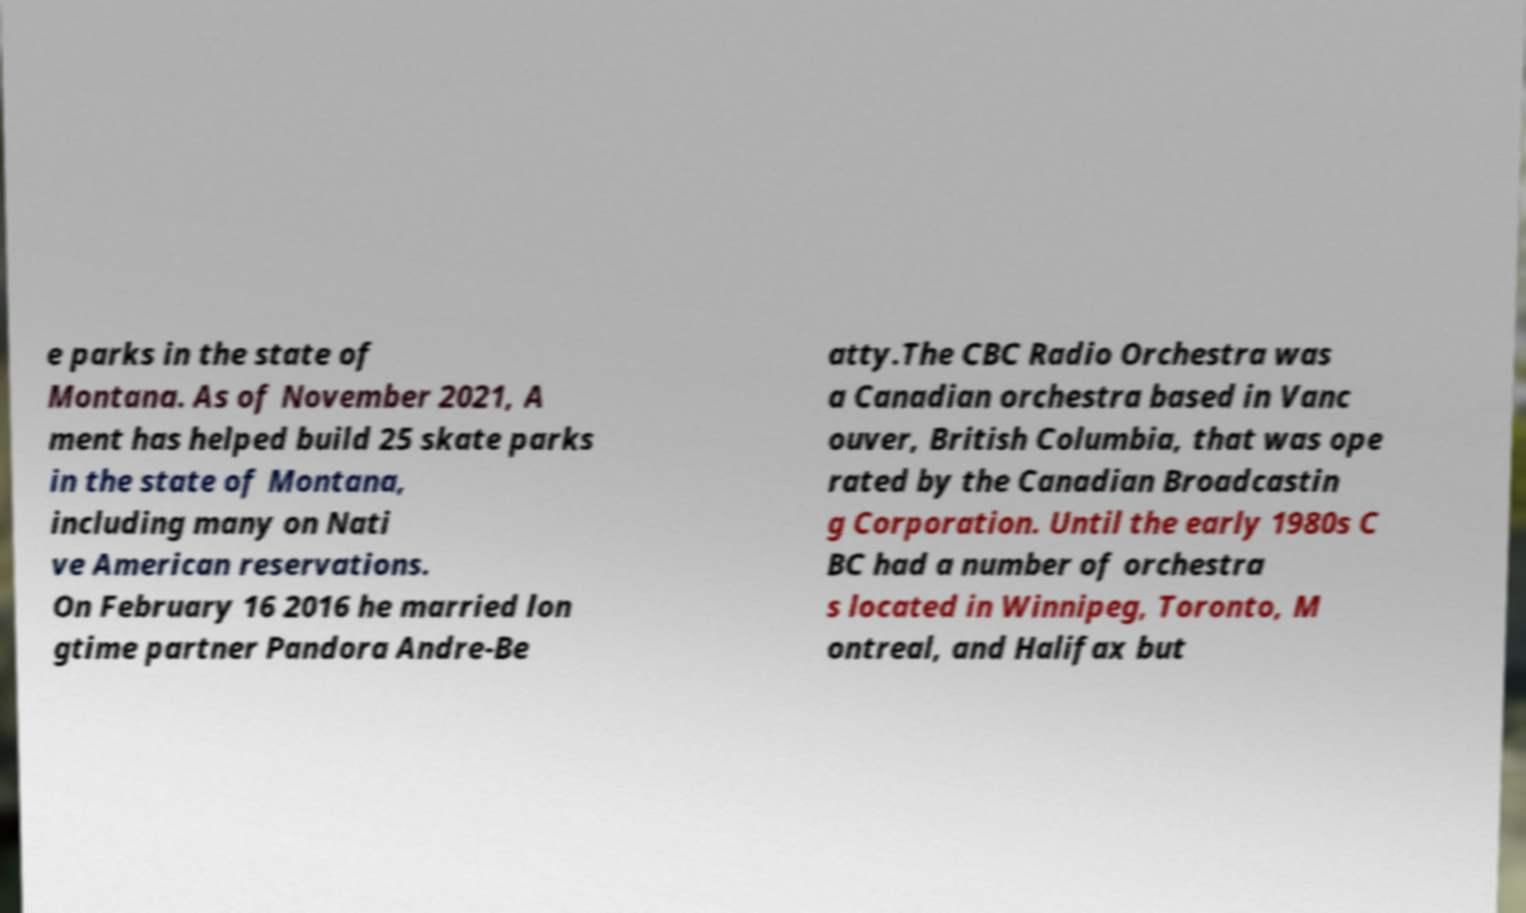Please read and relay the text visible in this image. What does it say? e parks in the state of Montana. As of November 2021, A ment has helped build 25 skate parks in the state of Montana, including many on Nati ve American reservations. On February 16 2016 he married lon gtime partner Pandora Andre-Be atty.The CBC Radio Orchestra was a Canadian orchestra based in Vanc ouver, British Columbia, that was ope rated by the Canadian Broadcastin g Corporation. Until the early 1980s C BC had a number of orchestra s located in Winnipeg, Toronto, M ontreal, and Halifax but 